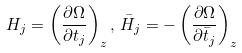<formula> <loc_0><loc_0><loc_500><loc_500>H _ { j } = \left ( \frac { \partial \Omega } { \partial t _ { j } } \right ) _ { z } , \, \bar { H } _ { j } = - \left ( \frac { \partial \Omega } { \partial \bar { t } _ { j } } \right ) _ { z }</formula> 